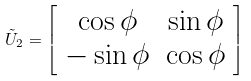<formula> <loc_0><loc_0><loc_500><loc_500>\tilde { U } _ { 2 } = \left [ \begin{array} { c c } \cos \phi & \sin \phi \\ - \sin \phi & \cos \phi \end{array} \right ]</formula> 